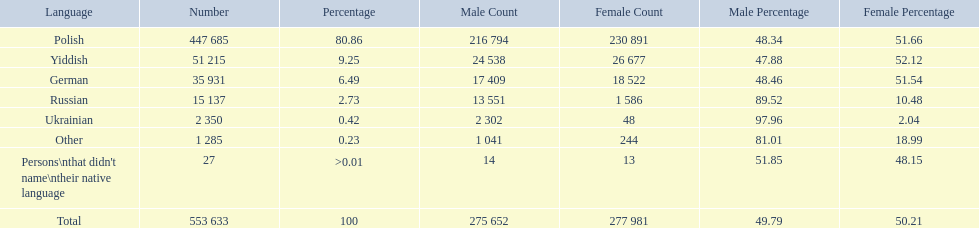What was the highest percentage of one language spoken by the plock governorate? 80.86. What language was spoken by 80.86 percent of the people? Polish. How many speakers are represented in polish? 447 685. How many represented speakers are yiddish? 51 215. What is the total number of speakers? 553 633. 